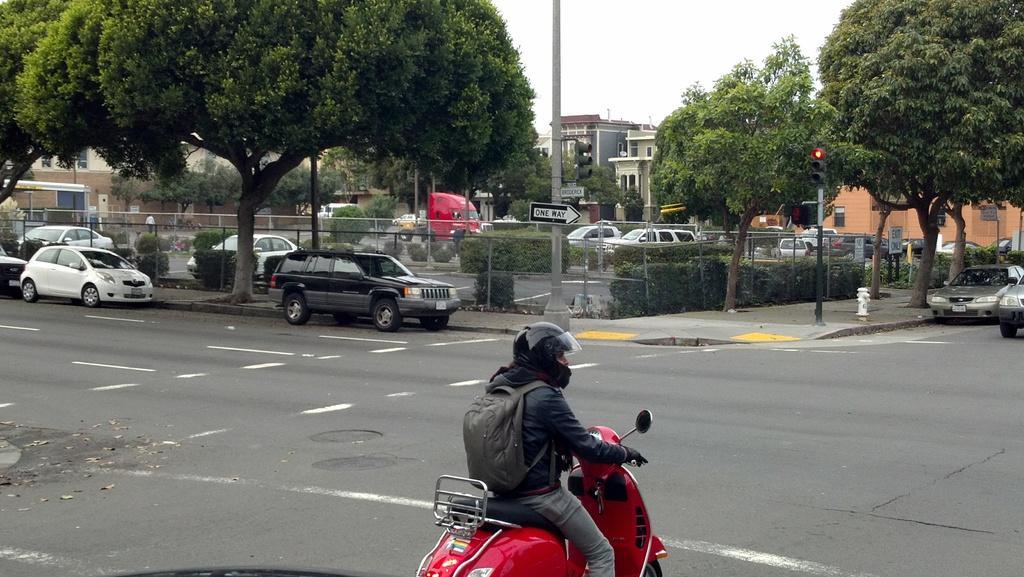Can you describe this image briefly? In the center of the image we can see a man sitting on the bike. In the background there are cars, trees, trucks, buildings, pole and sky. 